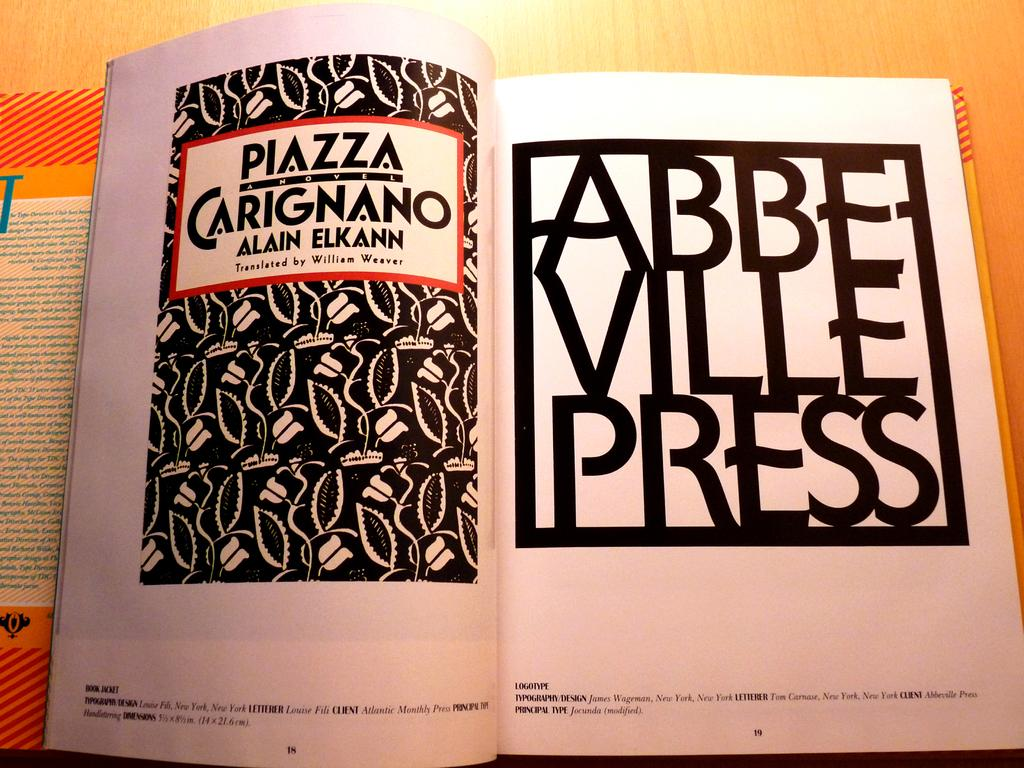<image>
Relay a brief, clear account of the picture shown. An open book with the tittle Piazza Carignano written on it. 